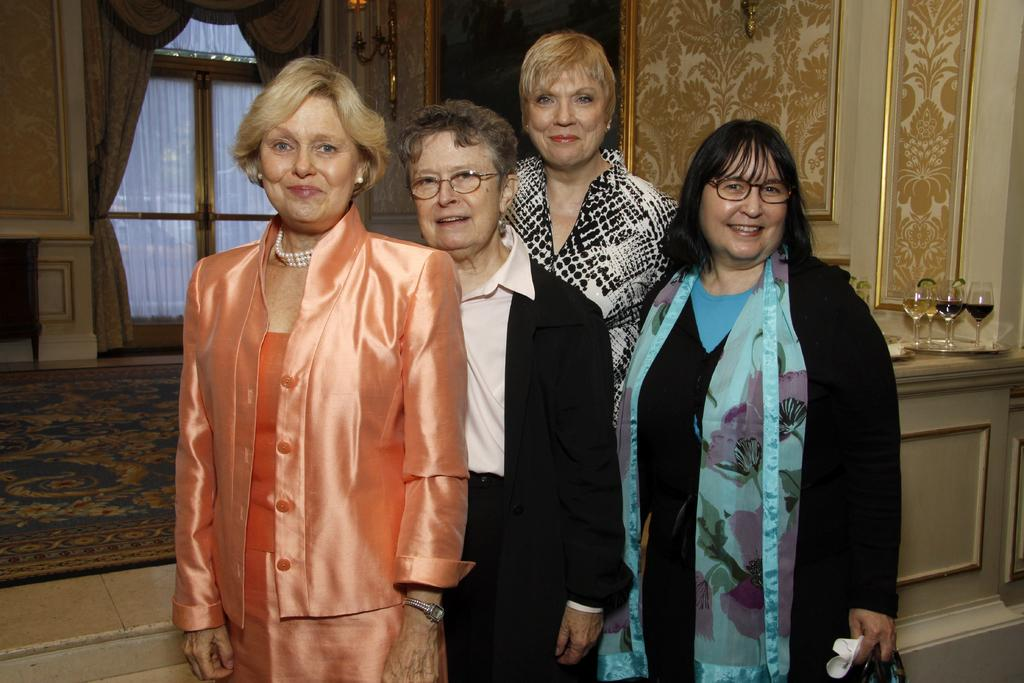How many women are present in the image? There are four women in the image. What are the women doing in the image? The women are standing and smiling. What can be seen in the background of the image? There are glasses, a carpet, walls, a window with curtains, and some objects visible in the background. What type of honey is being used to create harmony among the women in the image? There is no honey or indication of harmony among the women in the image. Are the women wearing shoes in the image? The image does not show the women's feet or shoes, so it cannot be determined from the image. 